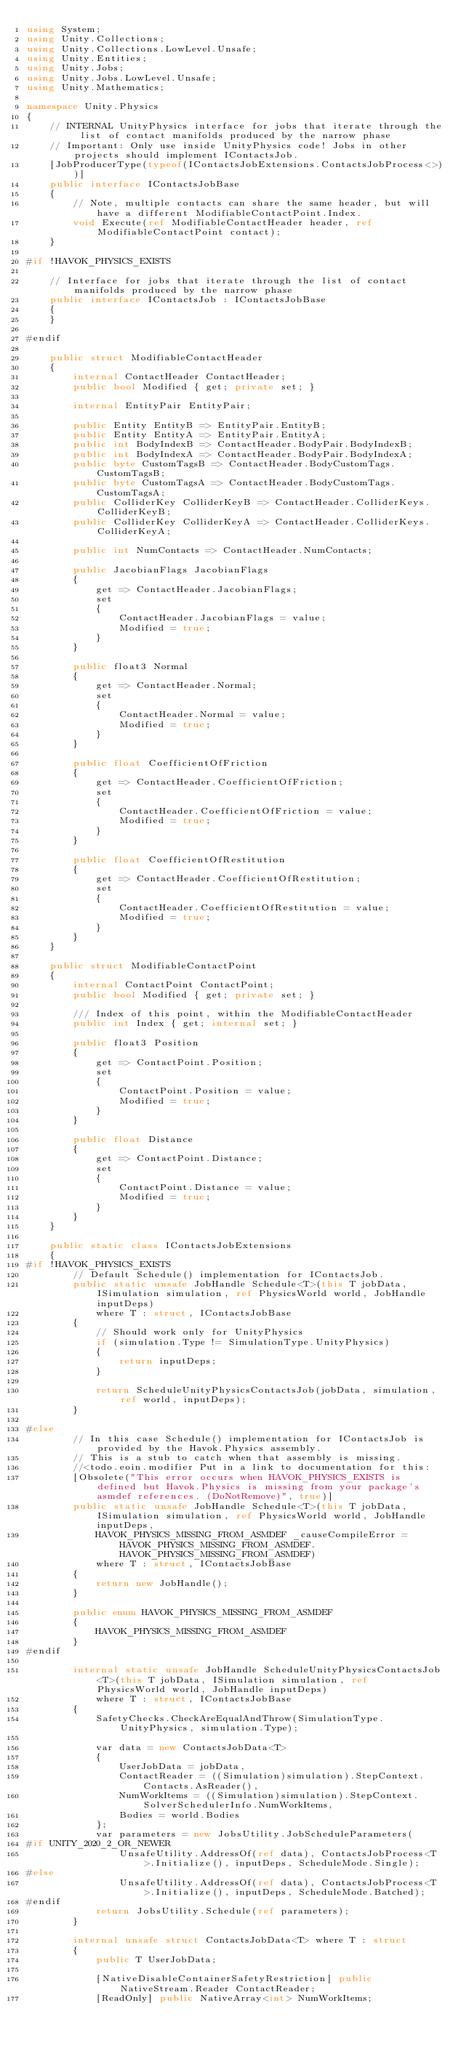<code> <loc_0><loc_0><loc_500><loc_500><_C#_>using System;
using Unity.Collections;
using Unity.Collections.LowLevel.Unsafe;
using Unity.Entities;
using Unity.Jobs;
using Unity.Jobs.LowLevel.Unsafe;
using Unity.Mathematics;

namespace Unity.Physics
{
    // INTERNAL UnityPhysics interface for jobs that iterate through the list of contact manifolds produced by the narrow phase
    // Important: Only use inside UnityPhysics code! Jobs in other projects should implement IContactsJob.
    [JobProducerType(typeof(IContactsJobExtensions.ContactsJobProcess<>))]
    public interface IContactsJobBase
    {
        // Note, multiple contacts can share the same header, but will have a different ModifiableContactPoint.Index.
        void Execute(ref ModifiableContactHeader header, ref ModifiableContactPoint contact);
    }

#if !HAVOK_PHYSICS_EXISTS

    // Interface for jobs that iterate through the list of contact manifolds produced by the narrow phase
    public interface IContactsJob : IContactsJobBase
    {
    }

#endif

    public struct ModifiableContactHeader
    {
        internal ContactHeader ContactHeader;
        public bool Modified { get; private set; }

        internal EntityPair EntityPair;

        public Entity EntityB => EntityPair.EntityB;
        public Entity EntityA => EntityPair.EntityA;
        public int BodyIndexB => ContactHeader.BodyPair.BodyIndexB;
        public int BodyIndexA => ContactHeader.BodyPair.BodyIndexA;
        public byte CustomTagsB => ContactHeader.BodyCustomTags.CustomTagsB;
        public byte CustomTagsA => ContactHeader.BodyCustomTags.CustomTagsA;
        public ColliderKey ColliderKeyB => ContactHeader.ColliderKeys.ColliderKeyB;
        public ColliderKey ColliderKeyA => ContactHeader.ColliderKeys.ColliderKeyA;

        public int NumContacts => ContactHeader.NumContacts;

        public JacobianFlags JacobianFlags
        {
            get => ContactHeader.JacobianFlags;
            set
            {
                ContactHeader.JacobianFlags = value;
                Modified = true;
            }
        }

        public float3 Normal
        {
            get => ContactHeader.Normal;
            set
            {
                ContactHeader.Normal = value;
                Modified = true;
            }
        }

        public float CoefficientOfFriction
        {
            get => ContactHeader.CoefficientOfFriction;
            set
            {
                ContactHeader.CoefficientOfFriction = value;
                Modified = true;
            }
        }

        public float CoefficientOfRestitution
        {
            get => ContactHeader.CoefficientOfRestitution;
            set
            {
                ContactHeader.CoefficientOfRestitution = value;
                Modified = true;
            }
        }
    }

    public struct ModifiableContactPoint
    {
        internal ContactPoint ContactPoint;
        public bool Modified { get; private set; }

        /// Index of this point, within the ModifiableContactHeader
        public int Index { get; internal set; }

        public float3 Position
        {
            get => ContactPoint.Position;
            set
            {
                ContactPoint.Position = value;
                Modified = true;
            }
        }

        public float Distance
        {
            get => ContactPoint.Distance;
            set
            {
                ContactPoint.Distance = value;
                Modified = true;
            }
        }
    }

    public static class IContactsJobExtensions
    {
#if !HAVOK_PHYSICS_EXISTS
        // Default Schedule() implementation for IContactsJob.
        public static unsafe JobHandle Schedule<T>(this T jobData, ISimulation simulation, ref PhysicsWorld world, JobHandle inputDeps)
            where T : struct, IContactsJobBase
        {
            // Should work only for UnityPhysics
            if (simulation.Type != SimulationType.UnityPhysics)
            {
                return inputDeps;
            }

            return ScheduleUnityPhysicsContactsJob(jobData, simulation, ref world, inputDeps);
        }

#else
        // In this case Schedule() implementation for IContactsJob is provided by the Havok.Physics assembly.
        // This is a stub to catch when that assembly is missing.
        //<todo.eoin.modifier Put in a link to documentation for this:
        [Obsolete("This error occurs when HAVOK_PHYSICS_EXISTS is defined but Havok.Physics is missing from your package's asmdef references. (DoNotRemove)", true)]
        public static unsafe JobHandle Schedule<T>(this T jobData, ISimulation simulation, ref PhysicsWorld world, JobHandle inputDeps,
            HAVOK_PHYSICS_MISSING_FROM_ASMDEF _causeCompileError = HAVOK_PHYSICS_MISSING_FROM_ASMDEF.HAVOK_PHYSICS_MISSING_FROM_ASMDEF)
            where T : struct, IContactsJobBase
        {
            return new JobHandle();
        }

        public enum HAVOK_PHYSICS_MISSING_FROM_ASMDEF
        {
            HAVOK_PHYSICS_MISSING_FROM_ASMDEF
        }
#endif

        internal static unsafe JobHandle ScheduleUnityPhysicsContactsJob<T>(this T jobData, ISimulation simulation, ref PhysicsWorld world, JobHandle inputDeps)
            where T : struct, IContactsJobBase
        {
            SafetyChecks.CheckAreEqualAndThrow(SimulationType.UnityPhysics, simulation.Type);

            var data = new ContactsJobData<T>
            {
                UserJobData = jobData,
                ContactReader = ((Simulation)simulation).StepContext.Contacts.AsReader(),
                NumWorkItems = ((Simulation)simulation).StepContext.SolverSchedulerInfo.NumWorkItems,
                Bodies = world.Bodies
            };
            var parameters = new JobsUtility.JobScheduleParameters(
#if UNITY_2020_2_OR_NEWER
                UnsafeUtility.AddressOf(ref data), ContactsJobProcess<T>.Initialize(), inputDeps, ScheduleMode.Single);
#else
                UnsafeUtility.AddressOf(ref data), ContactsJobProcess<T>.Initialize(), inputDeps, ScheduleMode.Batched);
#endif
            return JobsUtility.Schedule(ref parameters);
        }

        internal unsafe struct ContactsJobData<T> where T : struct
        {
            public T UserJobData;

            [NativeDisableContainerSafetyRestriction] public NativeStream.Reader ContactReader;
            [ReadOnly] public NativeArray<int> NumWorkItems;</code> 